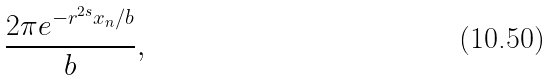<formula> <loc_0><loc_0><loc_500><loc_500>\frac { 2 \pi e ^ { - r ^ { 2 s } x _ { n } / b } } { b } ,</formula> 